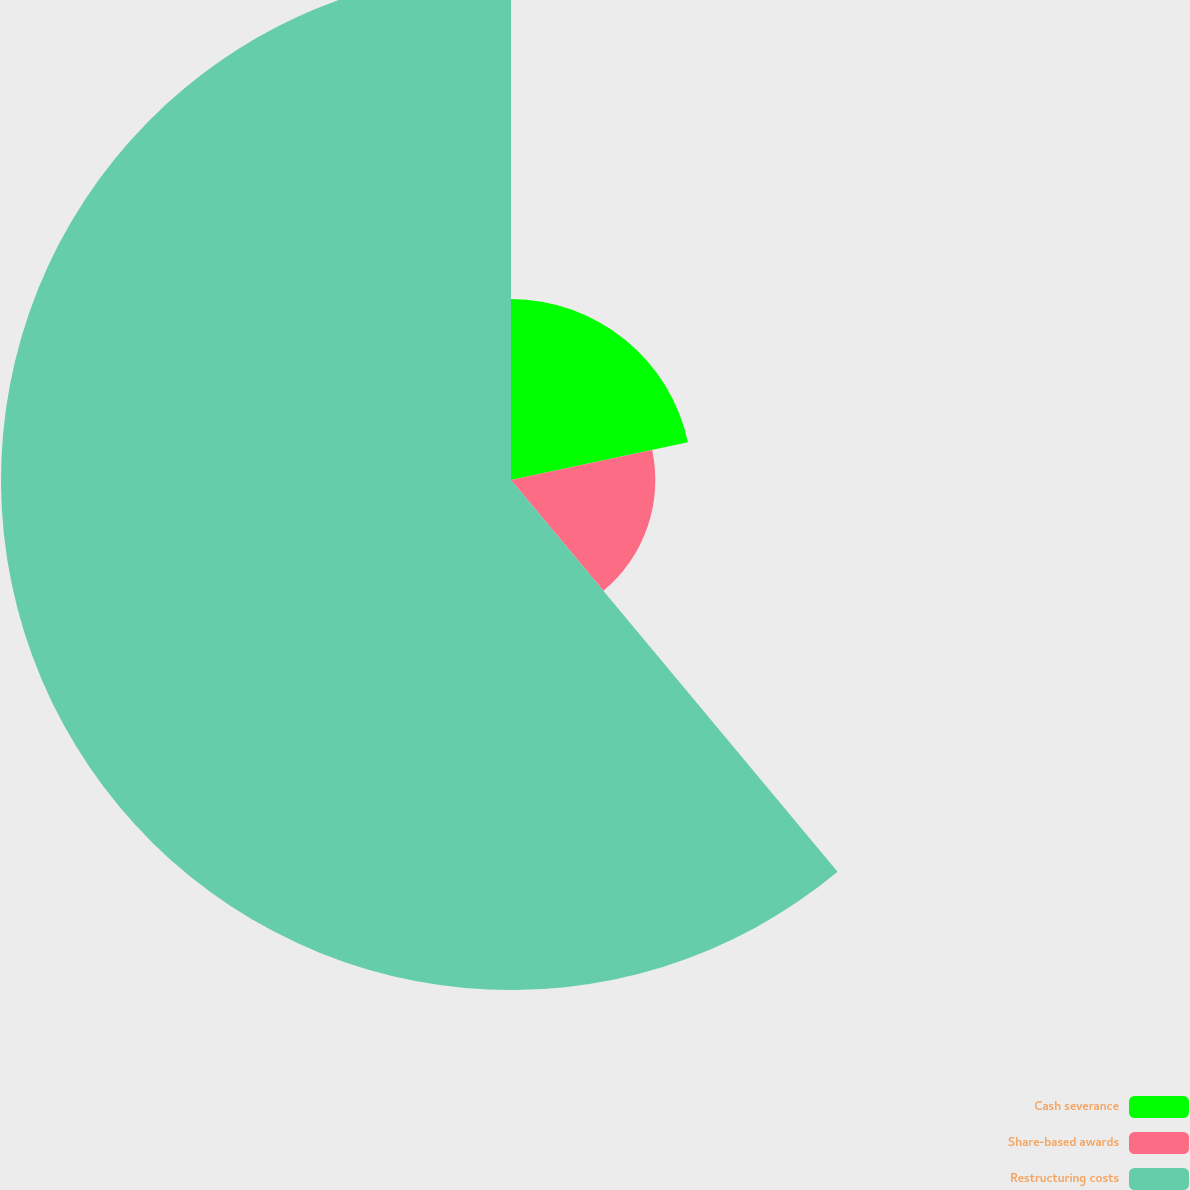Convert chart to OTSL. <chart><loc_0><loc_0><loc_500><loc_500><pie_chart><fcel>Cash severance<fcel>Share-based awards<fcel>Restructuring costs<nl><fcel>21.66%<fcel>17.28%<fcel>61.06%<nl></chart> 